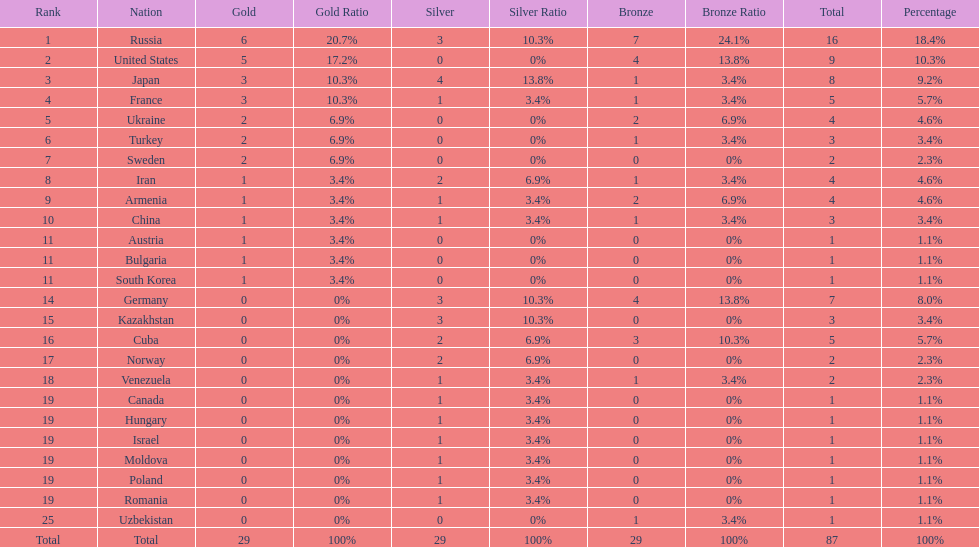How many silver medals did turkey win? 0. 